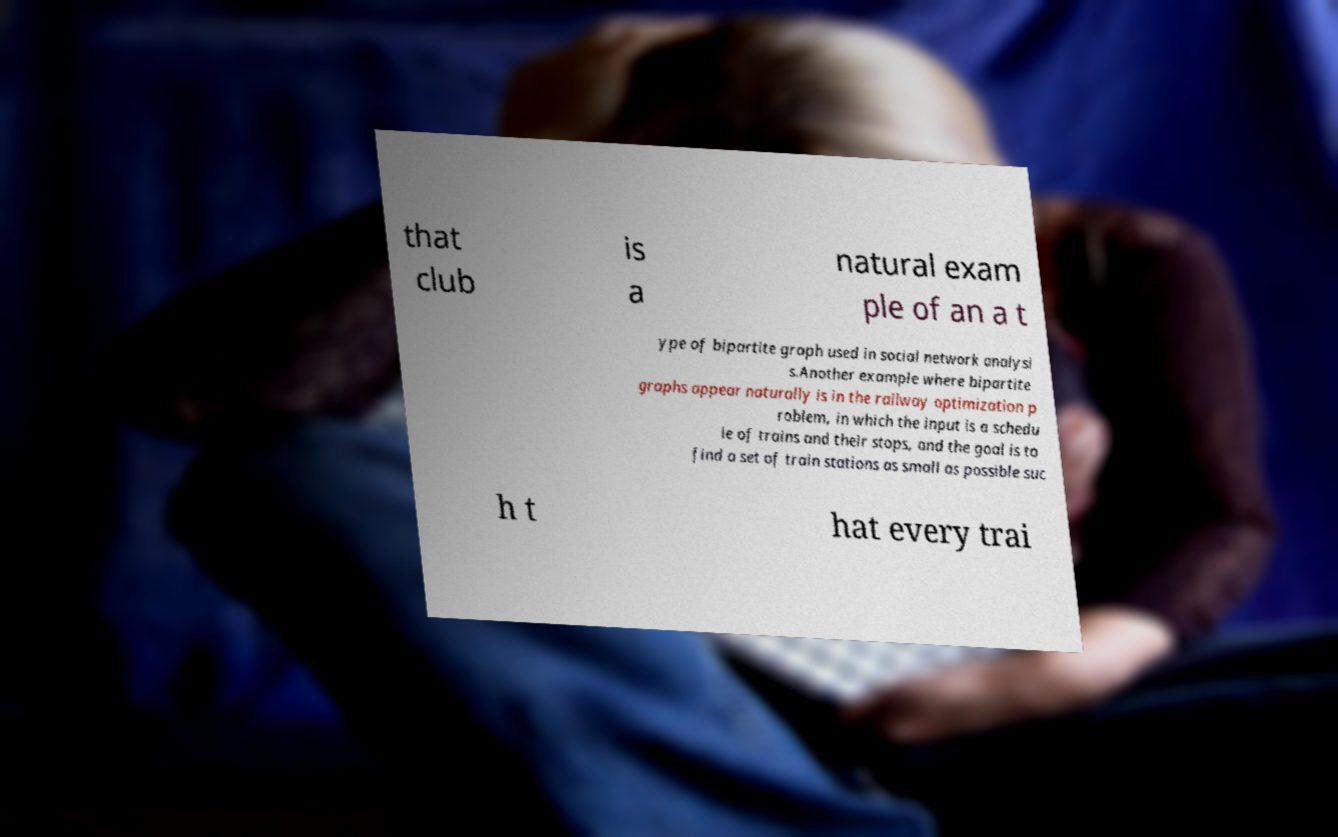Please identify and transcribe the text found in this image. that club is a natural exam ple of an a t ype of bipartite graph used in social network analysi s.Another example where bipartite graphs appear naturally is in the railway optimization p roblem, in which the input is a schedu le of trains and their stops, and the goal is to find a set of train stations as small as possible suc h t hat every trai 